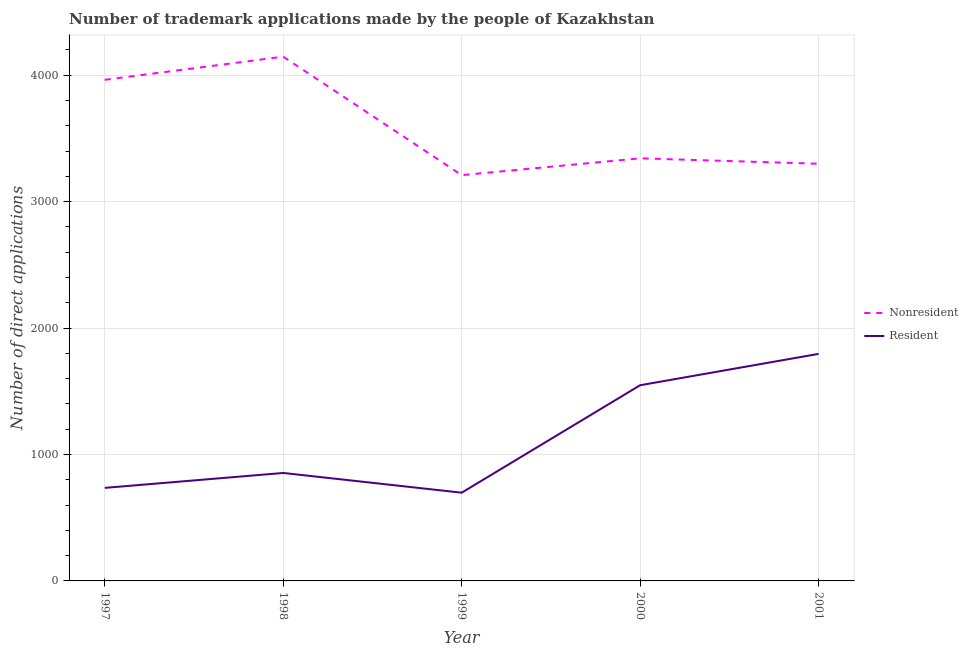How many different coloured lines are there?
Your response must be concise. 2. What is the number of trademark applications made by non residents in 2001?
Your answer should be very brief. 3300. Across all years, what is the maximum number of trademark applications made by non residents?
Offer a very short reply. 4147. Across all years, what is the minimum number of trademark applications made by residents?
Keep it short and to the point. 698. In which year was the number of trademark applications made by non residents maximum?
Provide a succinct answer. 1998. What is the total number of trademark applications made by residents in the graph?
Keep it short and to the point. 5632. What is the difference between the number of trademark applications made by residents in 1998 and that in 2000?
Keep it short and to the point. -694. What is the difference between the number of trademark applications made by residents in 1998 and the number of trademark applications made by non residents in 2000?
Your answer should be very brief. -2489. What is the average number of trademark applications made by non residents per year?
Provide a short and direct response. 3592.8. In the year 1997, what is the difference between the number of trademark applications made by residents and number of trademark applications made by non residents?
Ensure brevity in your answer.  -3228. What is the ratio of the number of trademark applications made by non residents in 1997 to that in 2001?
Ensure brevity in your answer.  1.2. Is the difference between the number of trademark applications made by non residents in 1999 and 2001 greater than the difference between the number of trademark applications made by residents in 1999 and 2001?
Your response must be concise. Yes. What is the difference between the highest and the second highest number of trademark applications made by residents?
Keep it short and to the point. 248. What is the difference between the highest and the lowest number of trademark applications made by residents?
Give a very brief answer. 1098. In how many years, is the number of trademark applications made by residents greater than the average number of trademark applications made by residents taken over all years?
Your answer should be compact. 2. Is the sum of the number of trademark applications made by non residents in 1997 and 2001 greater than the maximum number of trademark applications made by residents across all years?
Your answer should be compact. Yes. Is the number of trademark applications made by non residents strictly less than the number of trademark applications made by residents over the years?
Your answer should be very brief. No. How many years are there in the graph?
Keep it short and to the point. 5. Are the values on the major ticks of Y-axis written in scientific E-notation?
Offer a terse response. No. Does the graph contain any zero values?
Keep it short and to the point. No. Does the graph contain grids?
Offer a terse response. Yes. Where does the legend appear in the graph?
Your answer should be compact. Center right. How are the legend labels stacked?
Your answer should be compact. Vertical. What is the title of the graph?
Provide a short and direct response. Number of trademark applications made by the people of Kazakhstan. Does "Drinking water services" appear as one of the legend labels in the graph?
Provide a succinct answer. No. What is the label or title of the X-axis?
Give a very brief answer. Year. What is the label or title of the Y-axis?
Your response must be concise. Number of direct applications. What is the Number of direct applications of Nonresident in 1997?
Provide a succinct answer. 3964. What is the Number of direct applications of Resident in 1997?
Make the answer very short. 736. What is the Number of direct applications of Nonresident in 1998?
Provide a short and direct response. 4147. What is the Number of direct applications of Resident in 1998?
Your answer should be compact. 854. What is the Number of direct applications of Nonresident in 1999?
Your answer should be compact. 3210. What is the Number of direct applications in Resident in 1999?
Your answer should be compact. 698. What is the Number of direct applications in Nonresident in 2000?
Your answer should be very brief. 3343. What is the Number of direct applications of Resident in 2000?
Offer a terse response. 1548. What is the Number of direct applications of Nonresident in 2001?
Your response must be concise. 3300. What is the Number of direct applications of Resident in 2001?
Ensure brevity in your answer.  1796. Across all years, what is the maximum Number of direct applications in Nonresident?
Your answer should be compact. 4147. Across all years, what is the maximum Number of direct applications in Resident?
Give a very brief answer. 1796. Across all years, what is the minimum Number of direct applications of Nonresident?
Your answer should be compact. 3210. Across all years, what is the minimum Number of direct applications in Resident?
Your answer should be compact. 698. What is the total Number of direct applications in Nonresident in the graph?
Your answer should be very brief. 1.80e+04. What is the total Number of direct applications of Resident in the graph?
Make the answer very short. 5632. What is the difference between the Number of direct applications in Nonresident in 1997 and that in 1998?
Offer a very short reply. -183. What is the difference between the Number of direct applications in Resident in 1997 and that in 1998?
Make the answer very short. -118. What is the difference between the Number of direct applications in Nonresident in 1997 and that in 1999?
Provide a succinct answer. 754. What is the difference between the Number of direct applications in Nonresident in 1997 and that in 2000?
Offer a terse response. 621. What is the difference between the Number of direct applications of Resident in 1997 and that in 2000?
Provide a short and direct response. -812. What is the difference between the Number of direct applications in Nonresident in 1997 and that in 2001?
Keep it short and to the point. 664. What is the difference between the Number of direct applications in Resident in 1997 and that in 2001?
Your answer should be very brief. -1060. What is the difference between the Number of direct applications of Nonresident in 1998 and that in 1999?
Your answer should be compact. 937. What is the difference between the Number of direct applications of Resident in 1998 and that in 1999?
Offer a very short reply. 156. What is the difference between the Number of direct applications in Nonresident in 1998 and that in 2000?
Make the answer very short. 804. What is the difference between the Number of direct applications of Resident in 1998 and that in 2000?
Make the answer very short. -694. What is the difference between the Number of direct applications of Nonresident in 1998 and that in 2001?
Your answer should be very brief. 847. What is the difference between the Number of direct applications in Resident in 1998 and that in 2001?
Give a very brief answer. -942. What is the difference between the Number of direct applications in Nonresident in 1999 and that in 2000?
Offer a terse response. -133. What is the difference between the Number of direct applications of Resident in 1999 and that in 2000?
Offer a terse response. -850. What is the difference between the Number of direct applications of Nonresident in 1999 and that in 2001?
Provide a succinct answer. -90. What is the difference between the Number of direct applications of Resident in 1999 and that in 2001?
Your response must be concise. -1098. What is the difference between the Number of direct applications in Nonresident in 2000 and that in 2001?
Provide a short and direct response. 43. What is the difference between the Number of direct applications in Resident in 2000 and that in 2001?
Offer a very short reply. -248. What is the difference between the Number of direct applications in Nonresident in 1997 and the Number of direct applications in Resident in 1998?
Offer a terse response. 3110. What is the difference between the Number of direct applications of Nonresident in 1997 and the Number of direct applications of Resident in 1999?
Give a very brief answer. 3266. What is the difference between the Number of direct applications in Nonresident in 1997 and the Number of direct applications in Resident in 2000?
Offer a terse response. 2416. What is the difference between the Number of direct applications in Nonresident in 1997 and the Number of direct applications in Resident in 2001?
Ensure brevity in your answer.  2168. What is the difference between the Number of direct applications in Nonresident in 1998 and the Number of direct applications in Resident in 1999?
Your answer should be very brief. 3449. What is the difference between the Number of direct applications in Nonresident in 1998 and the Number of direct applications in Resident in 2000?
Your response must be concise. 2599. What is the difference between the Number of direct applications of Nonresident in 1998 and the Number of direct applications of Resident in 2001?
Offer a very short reply. 2351. What is the difference between the Number of direct applications in Nonresident in 1999 and the Number of direct applications in Resident in 2000?
Make the answer very short. 1662. What is the difference between the Number of direct applications of Nonresident in 1999 and the Number of direct applications of Resident in 2001?
Your answer should be compact. 1414. What is the difference between the Number of direct applications of Nonresident in 2000 and the Number of direct applications of Resident in 2001?
Ensure brevity in your answer.  1547. What is the average Number of direct applications in Nonresident per year?
Ensure brevity in your answer.  3592.8. What is the average Number of direct applications of Resident per year?
Your answer should be compact. 1126.4. In the year 1997, what is the difference between the Number of direct applications in Nonresident and Number of direct applications in Resident?
Keep it short and to the point. 3228. In the year 1998, what is the difference between the Number of direct applications in Nonresident and Number of direct applications in Resident?
Offer a terse response. 3293. In the year 1999, what is the difference between the Number of direct applications of Nonresident and Number of direct applications of Resident?
Your answer should be compact. 2512. In the year 2000, what is the difference between the Number of direct applications in Nonresident and Number of direct applications in Resident?
Make the answer very short. 1795. In the year 2001, what is the difference between the Number of direct applications in Nonresident and Number of direct applications in Resident?
Offer a terse response. 1504. What is the ratio of the Number of direct applications in Nonresident in 1997 to that in 1998?
Give a very brief answer. 0.96. What is the ratio of the Number of direct applications in Resident in 1997 to that in 1998?
Provide a short and direct response. 0.86. What is the ratio of the Number of direct applications of Nonresident in 1997 to that in 1999?
Your answer should be very brief. 1.23. What is the ratio of the Number of direct applications in Resident in 1997 to that in 1999?
Your answer should be compact. 1.05. What is the ratio of the Number of direct applications of Nonresident in 1997 to that in 2000?
Provide a succinct answer. 1.19. What is the ratio of the Number of direct applications of Resident in 1997 to that in 2000?
Give a very brief answer. 0.48. What is the ratio of the Number of direct applications in Nonresident in 1997 to that in 2001?
Provide a succinct answer. 1.2. What is the ratio of the Number of direct applications of Resident in 1997 to that in 2001?
Ensure brevity in your answer.  0.41. What is the ratio of the Number of direct applications in Nonresident in 1998 to that in 1999?
Ensure brevity in your answer.  1.29. What is the ratio of the Number of direct applications in Resident in 1998 to that in 1999?
Offer a very short reply. 1.22. What is the ratio of the Number of direct applications of Nonresident in 1998 to that in 2000?
Offer a very short reply. 1.24. What is the ratio of the Number of direct applications in Resident in 1998 to that in 2000?
Provide a succinct answer. 0.55. What is the ratio of the Number of direct applications of Nonresident in 1998 to that in 2001?
Keep it short and to the point. 1.26. What is the ratio of the Number of direct applications in Resident in 1998 to that in 2001?
Keep it short and to the point. 0.48. What is the ratio of the Number of direct applications in Nonresident in 1999 to that in 2000?
Give a very brief answer. 0.96. What is the ratio of the Number of direct applications of Resident in 1999 to that in 2000?
Offer a terse response. 0.45. What is the ratio of the Number of direct applications in Nonresident in 1999 to that in 2001?
Make the answer very short. 0.97. What is the ratio of the Number of direct applications of Resident in 1999 to that in 2001?
Your answer should be very brief. 0.39. What is the ratio of the Number of direct applications in Nonresident in 2000 to that in 2001?
Make the answer very short. 1.01. What is the ratio of the Number of direct applications in Resident in 2000 to that in 2001?
Your answer should be compact. 0.86. What is the difference between the highest and the second highest Number of direct applications of Nonresident?
Your answer should be compact. 183. What is the difference between the highest and the second highest Number of direct applications of Resident?
Provide a short and direct response. 248. What is the difference between the highest and the lowest Number of direct applications of Nonresident?
Offer a terse response. 937. What is the difference between the highest and the lowest Number of direct applications of Resident?
Your answer should be compact. 1098. 